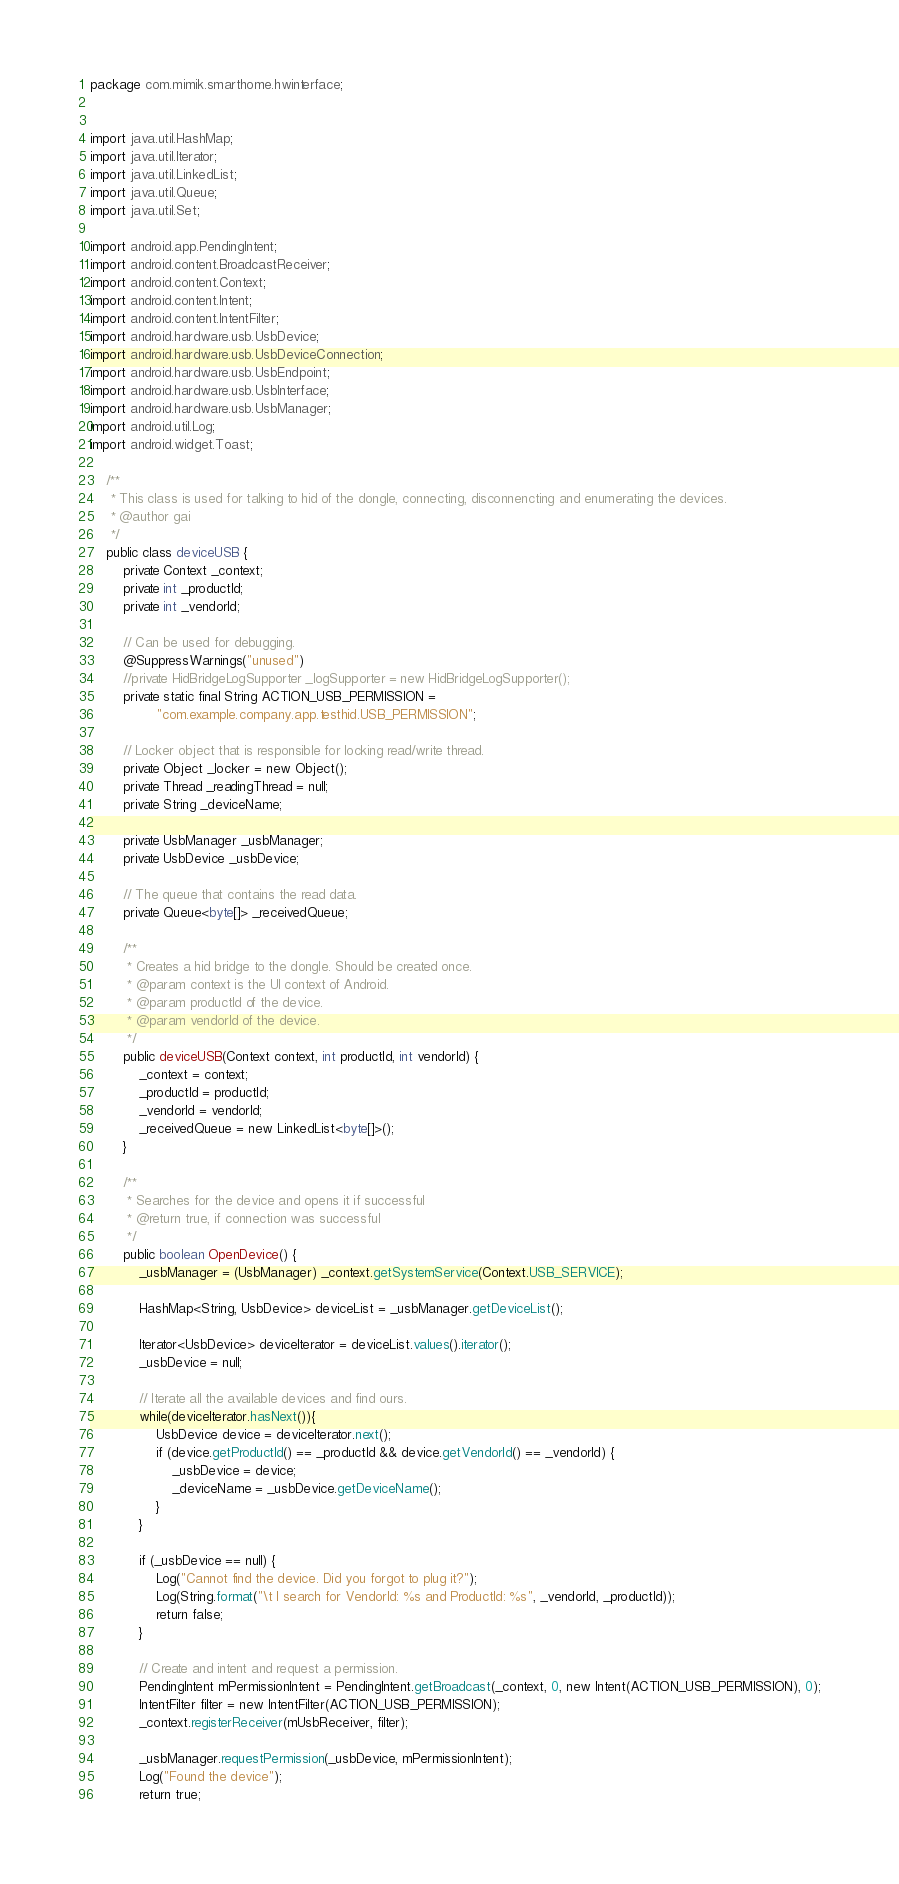<code> <loc_0><loc_0><loc_500><loc_500><_Java_>package com.mimik.smarthome.hwinterface;


import java.util.HashMap;
import java.util.Iterator;
import java.util.LinkedList;
import java.util.Queue;
import java.util.Set;

import android.app.PendingIntent;
import android.content.BroadcastReceiver;
import android.content.Context;
import android.content.Intent;
import android.content.IntentFilter;
import android.hardware.usb.UsbDevice;
import android.hardware.usb.UsbDeviceConnection;
import android.hardware.usb.UsbEndpoint;
import android.hardware.usb.UsbInterface;
import android.hardware.usb.UsbManager;
import android.util.Log;
import android.widget.Toast;

    /**
     * This class is used for talking to hid of the dongle, connecting, disconnencting and enumerating the devices.
     * @author gai
     */
    public class deviceUSB {
        private Context _context;
        private int _productId;
        private int _vendorId;

        // Can be used for debugging.
        @SuppressWarnings("unused")
        //private HidBridgeLogSupporter _logSupporter = new HidBridgeLogSupporter();
        private static final String ACTION_USB_PERMISSION =
                "com.example.company.app.testhid.USB_PERMISSION";

        // Locker object that is responsible for locking read/write thread.
        private Object _locker = new Object();
        private Thread _readingThread = null;
        private String _deviceName;

        private UsbManager _usbManager;
        private UsbDevice _usbDevice;

        // The queue that contains the read data.
        private Queue<byte[]> _receivedQueue;

        /**
         * Creates a hid bridge to the dongle. Should be created once.
         * @param context is the UI context of Android.
         * @param productId of the device.
         * @param vendorId of the device.
         */
        public deviceUSB(Context context, int productId, int vendorId) {
            _context = context;
            _productId = productId;
            _vendorId = vendorId;
            _receivedQueue = new LinkedList<byte[]>();
        }

        /**
         * Searches for the device and opens it if successful
         * @return true, if connection was successful
         */
        public boolean OpenDevice() {
            _usbManager = (UsbManager) _context.getSystemService(Context.USB_SERVICE);

            HashMap<String, UsbDevice> deviceList = _usbManager.getDeviceList();

            Iterator<UsbDevice> deviceIterator = deviceList.values().iterator();
            _usbDevice = null;

            // Iterate all the available devices and find ours.
            while(deviceIterator.hasNext()){
                UsbDevice device = deviceIterator.next();
                if (device.getProductId() == _productId && device.getVendorId() == _vendorId) {
                    _usbDevice = device;
                    _deviceName = _usbDevice.getDeviceName();
                }
            }

            if (_usbDevice == null) {
                Log("Cannot find the device. Did you forgot to plug it?");
                Log(String.format("\t I search for VendorId: %s and ProductId: %s", _vendorId, _productId));
                return false;
            }

            // Create and intent and request a permission.
            PendingIntent mPermissionIntent = PendingIntent.getBroadcast(_context, 0, new Intent(ACTION_USB_PERMISSION), 0);
            IntentFilter filter = new IntentFilter(ACTION_USB_PERMISSION);
            _context.registerReceiver(mUsbReceiver, filter);

            _usbManager.requestPermission(_usbDevice, mPermissionIntent);
            Log("Found the device");
            return true;</code> 